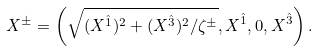Convert formula to latex. <formula><loc_0><loc_0><loc_500><loc_500>X ^ { \pm } = \left ( \sqrt { ( X ^ { \hat { 1 } } ) ^ { 2 } + ( X ^ { \hat { 3 } } ) ^ { 2 } / \zeta ^ { \pm } } , X ^ { \hat { 1 } } , 0 , X ^ { \hat { 3 } } \right ) .</formula> 